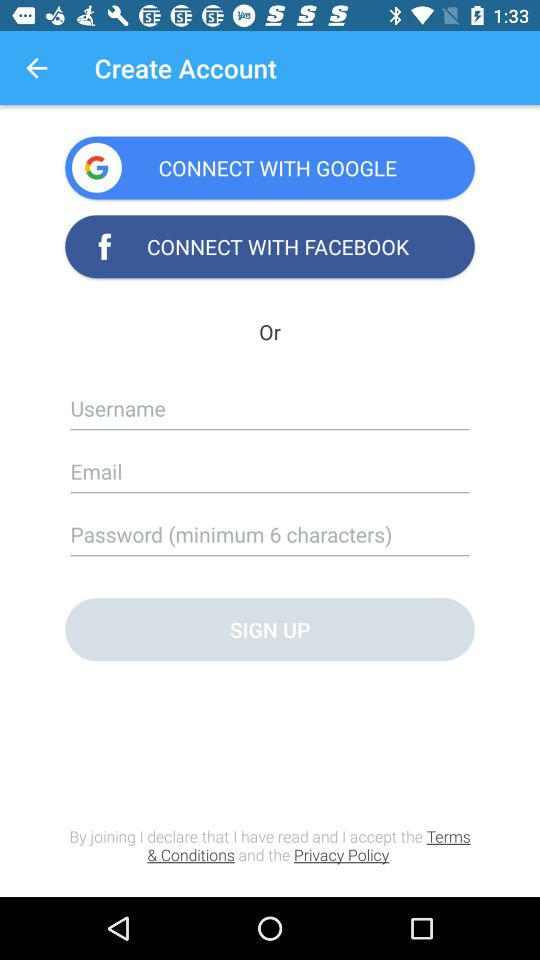Through what applications can a user connect with? User can connect with "GOOGLE" and "FACEBOOK". 